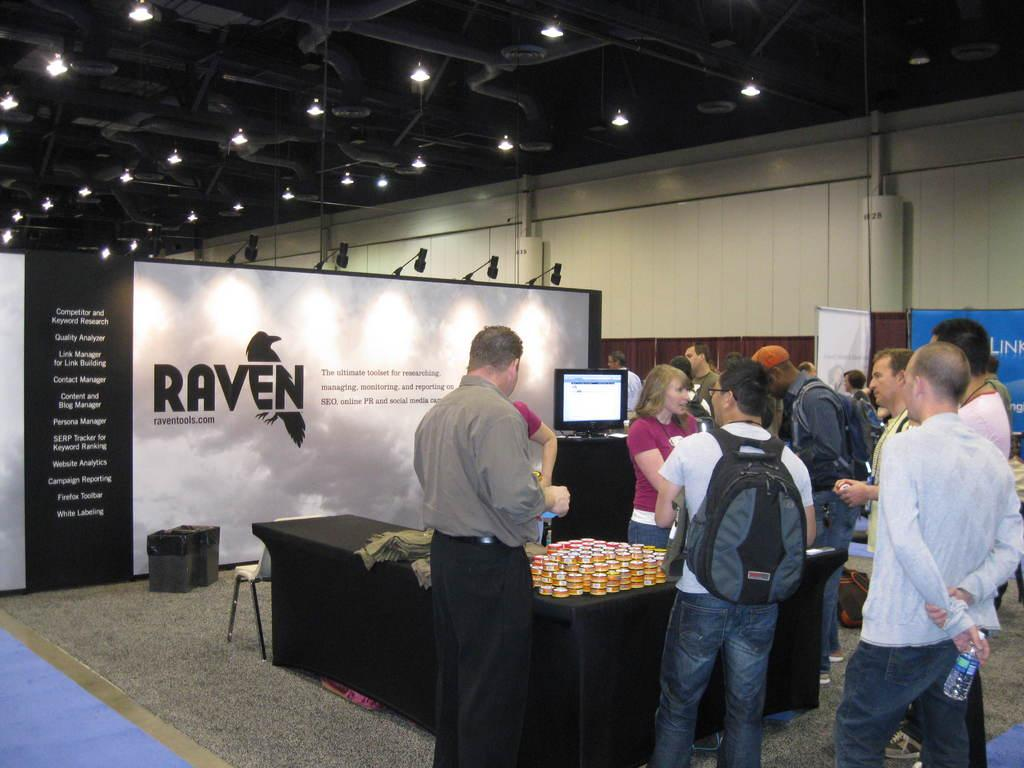What is happening in the image? There are people standing in front of a table. Can you describe the table in the image? The table is black. What can be found on the table? There are objects on the table. What is visible in the background of the image? There is a board in the background. What is written or displayed on the board? Something is written on the board. How much profit did the houses in the image generate last year? There are no houses present in the image, so it is not possible to determine the profit generated by any houses. 